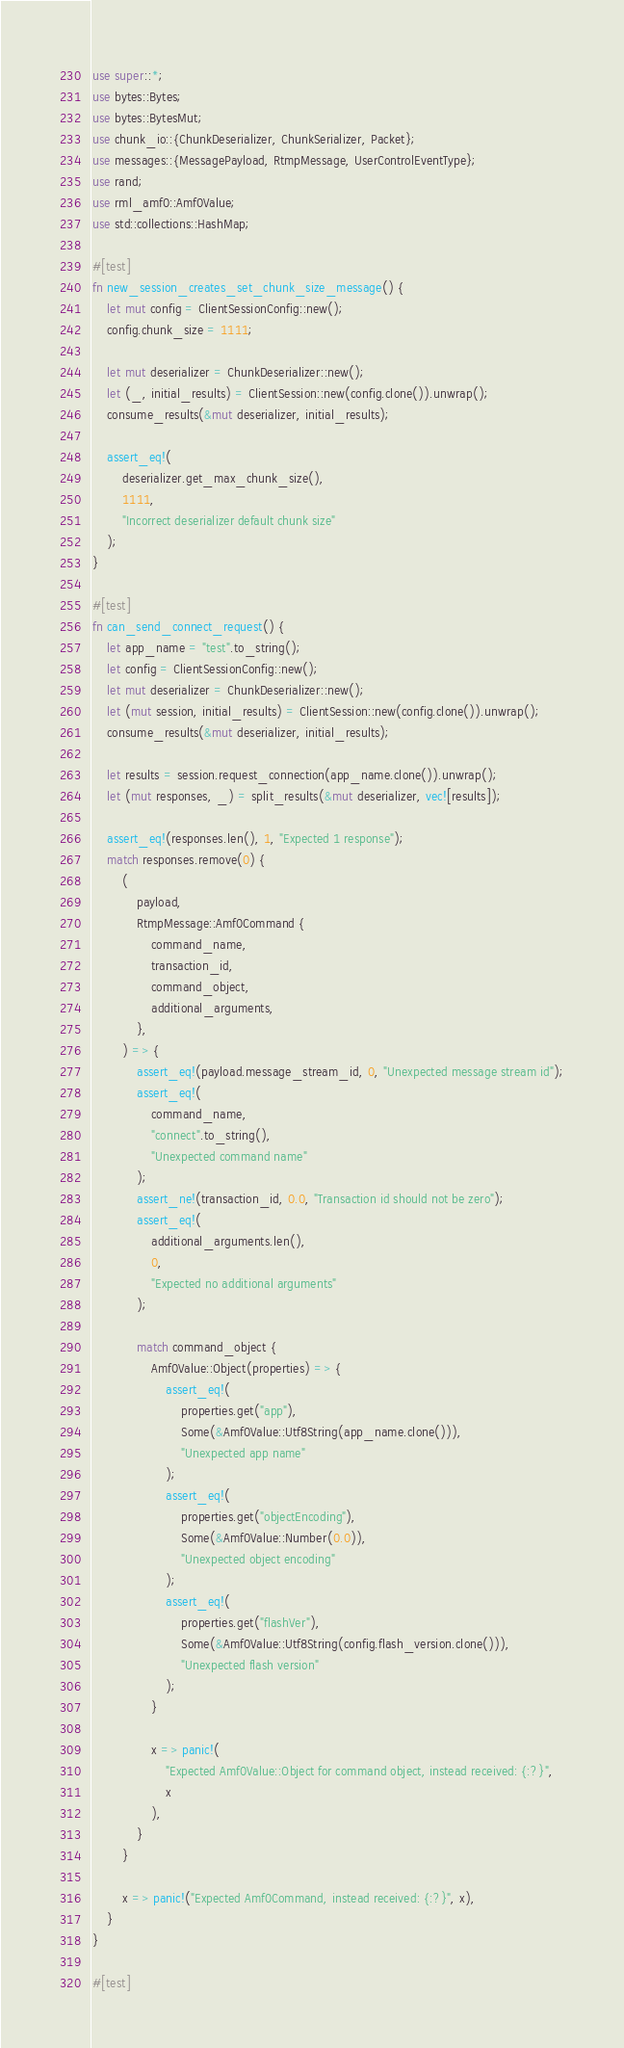<code> <loc_0><loc_0><loc_500><loc_500><_Rust_>use super::*;
use bytes::Bytes;
use bytes::BytesMut;
use chunk_io::{ChunkDeserializer, ChunkSerializer, Packet};
use messages::{MessagePayload, RtmpMessage, UserControlEventType};
use rand;
use rml_amf0::Amf0Value;
use std::collections::HashMap;

#[test]
fn new_session_creates_set_chunk_size_message() {
    let mut config = ClientSessionConfig::new();
    config.chunk_size = 1111;

    let mut deserializer = ChunkDeserializer::new();
    let (_, initial_results) = ClientSession::new(config.clone()).unwrap();
    consume_results(&mut deserializer, initial_results);

    assert_eq!(
        deserializer.get_max_chunk_size(),
        1111,
        "Incorrect deserializer default chunk size"
    );
}

#[test]
fn can_send_connect_request() {
    let app_name = "test".to_string();
    let config = ClientSessionConfig::new();
    let mut deserializer = ChunkDeserializer::new();
    let (mut session, initial_results) = ClientSession::new(config.clone()).unwrap();
    consume_results(&mut deserializer, initial_results);

    let results = session.request_connection(app_name.clone()).unwrap();
    let (mut responses, _) = split_results(&mut deserializer, vec![results]);

    assert_eq!(responses.len(), 1, "Expected 1 response");
    match responses.remove(0) {
        (
            payload,
            RtmpMessage::Amf0Command {
                command_name,
                transaction_id,
                command_object,
                additional_arguments,
            },
        ) => {
            assert_eq!(payload.message_stream_id, 0, "Unexpected message stream id");
            assert_eq!(
                command_name,
                "connect".to_string(),
                "Unexpected command name"
            );
            assert_ne!(transaction_id, 0.0, "Transaction id should not be zero");
            assert_eq!(
                additional_arguments.len(),
                0,
                "Expected no additional arguments"
            );

            match command_object {
                Amf0Value::Object(properties) => {
                    assert_eq!(
                        properties.get("app"),
                        Some(&Amf0Value::Utf8String(app_name.clone())),
                        "Unexpected app name"
                    );
                    assert_eq!(
                        properties.get("objectEncoding"),
                        Some(&Amf0Value::Number(0.0)),
                        "Unexpected object encoding"
                    );
                    assert_eq!(
                        properties.get("flashVer"),
                        Some(&Amf0Value::Utf8String(config.flash_version.clone())),
                        "Unexpected flash version"
                    );
                }

                x => panic!(
                    "Expected Amf0Value::Object for command object, instead received: {:?}",
                    x
                ),
            }
        }

        x => panic!("Expected Amf0Command, instead received: {:?}", x),
    }
}

#[test]</code> 